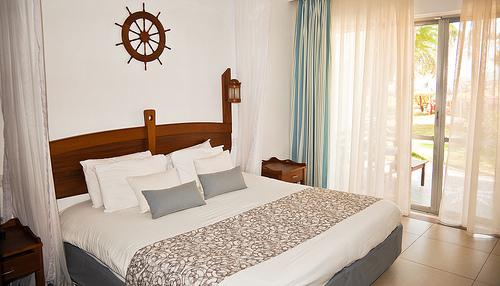Question: why is there a bed?
Choices:
A. For people to lay on.
B. To rest.
C. To sleep.
D. To work.
Answer with the letter. Answer: A Question: what kind of floor is it?
Choices:
A. Rug.
B. Tile.
C. Hardwood.
D. Concrete.
Answer with the letter. Answer: B 